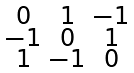<formula> <loc_0><loc_0><loc_500><loc_500>\begin{smallmatrix} 0 & 1 & - 1 \\ - 1 & 0 & 1 \\ 1 & - 1 & 0 \\ \end{smallmatrix}</formula> 